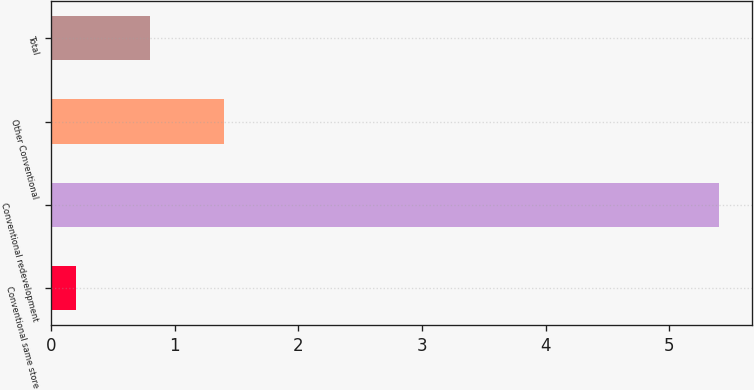Convert chart to OTSL. <chart><loc_0><loc_0><loc_500><loc_500><bar_chart><fcel>Conventional same store<fcel>Conventional redevelopment<fcel>Other Conventional<fcel>Total<nl><fcel>0.2<fcel>5.4<fcel>1.4<fcel>0.8<nl></chart> 